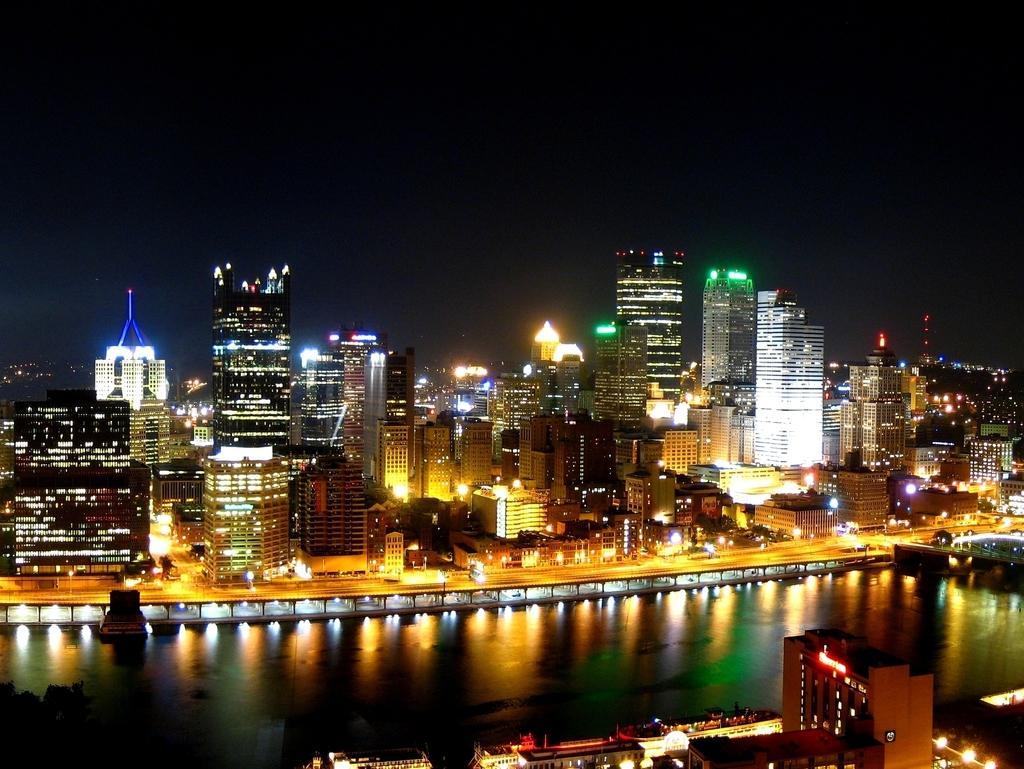How would you summarize this image in a sentence or two? These are the buildings with lights, this is the water. At the top it's a sky in the night. 